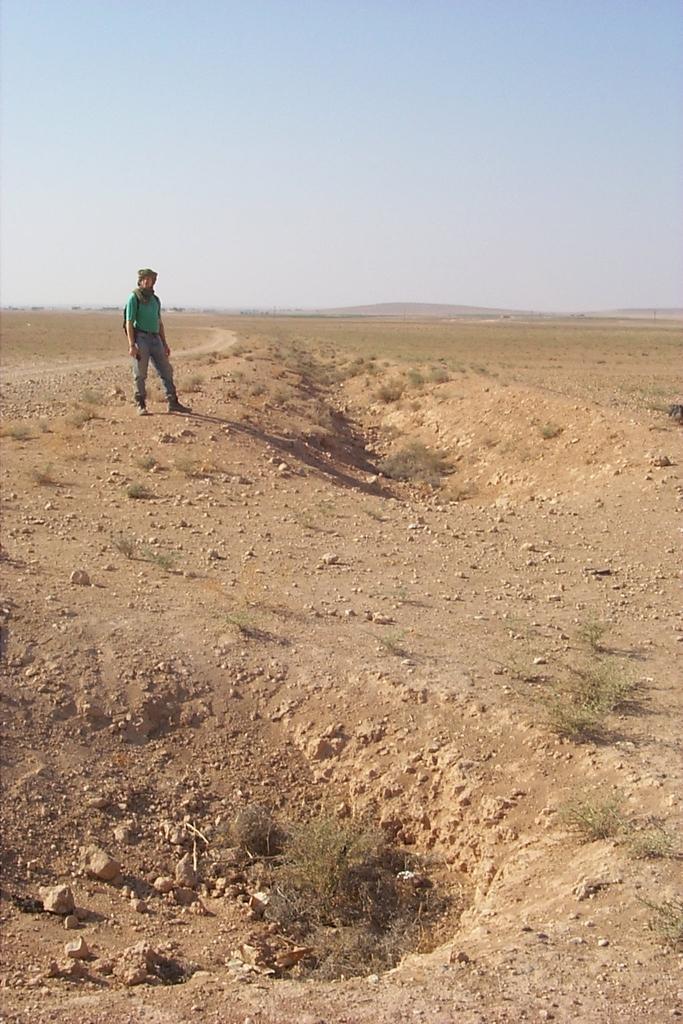Can you describe this image briefly? In the background we can see sky. Here we can see man wearing a t-shirt and standing. Here we can see stones on the ground. 